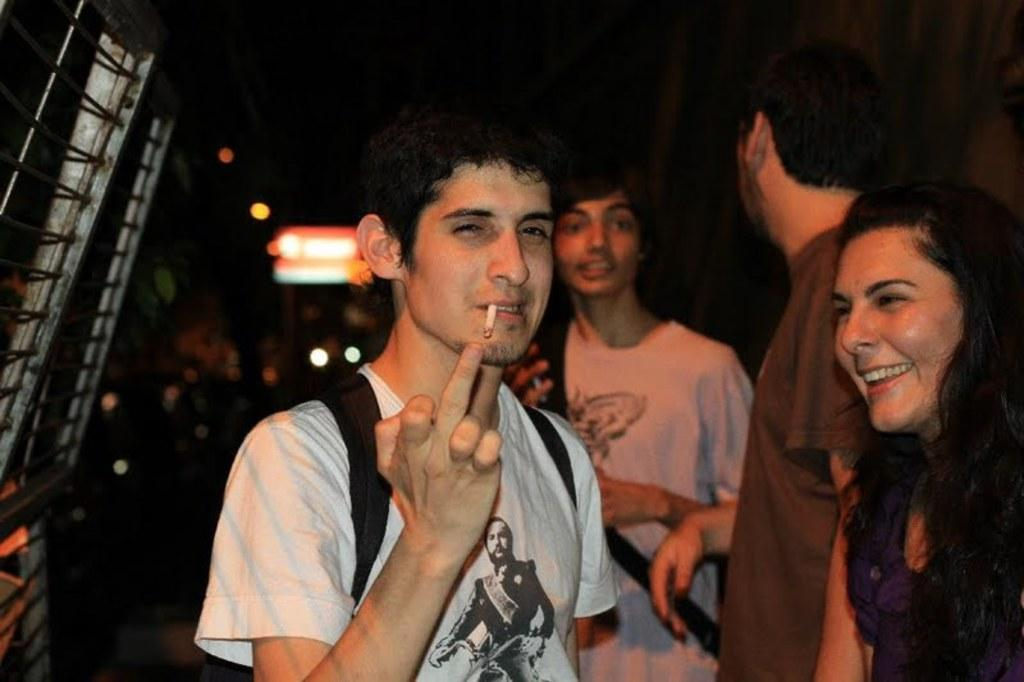What can be seen in the image? There are people standing in the image. What are the people wearing? The people are wearing bags. What can be seen in the background of the image? There are lights visible in the background. How would you describe the overall lighting in the image? The background of the image is dark. What type of flower can be seen growing in the bags that the people are wearing? There are no flowers present in the image, and the people are wearing bags, not growing flowers. 